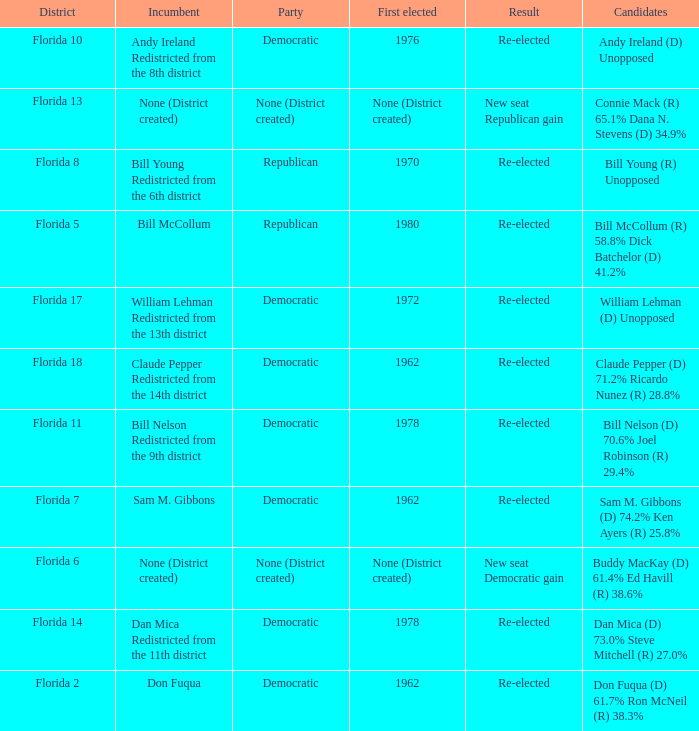What's the result with district being florida 7 Re-elected. 